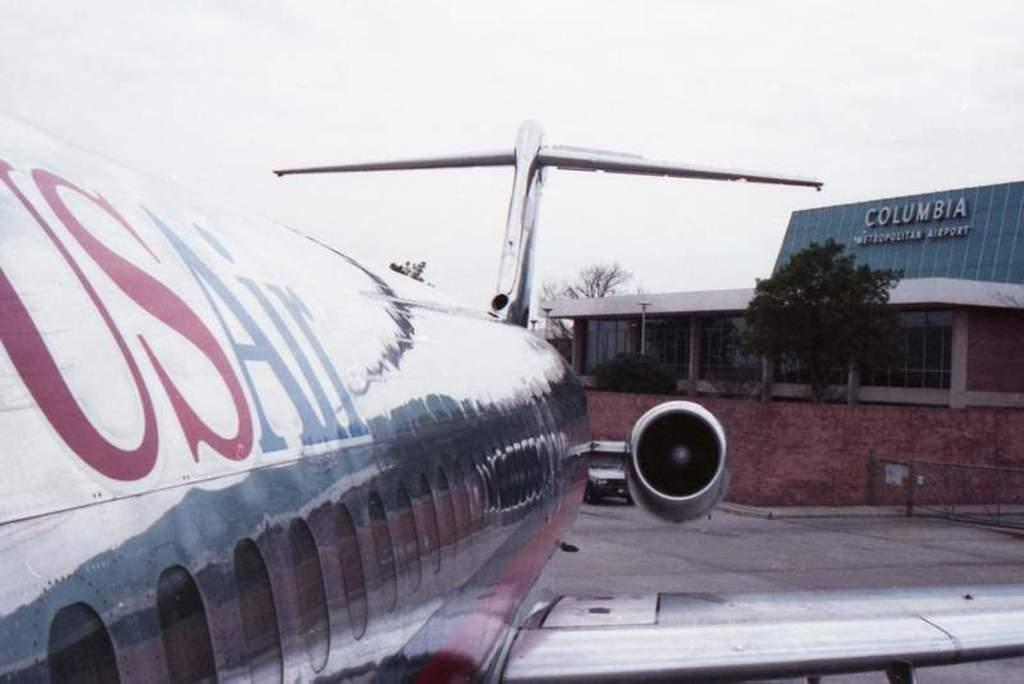What is the main subject of the picture, despite being truncated? The main subject of the picture is an airplane, even though it appears to be truncated. What can be seen in the background of the image? There is a building, trees, a board, and the sky visible in the background of the image. What type of cherry is being ploughed in the image? There is no cherry or ploughing activity present in the image. How does the board rub against the building in the image? There is no rubbing action between the board and the building in the image. 